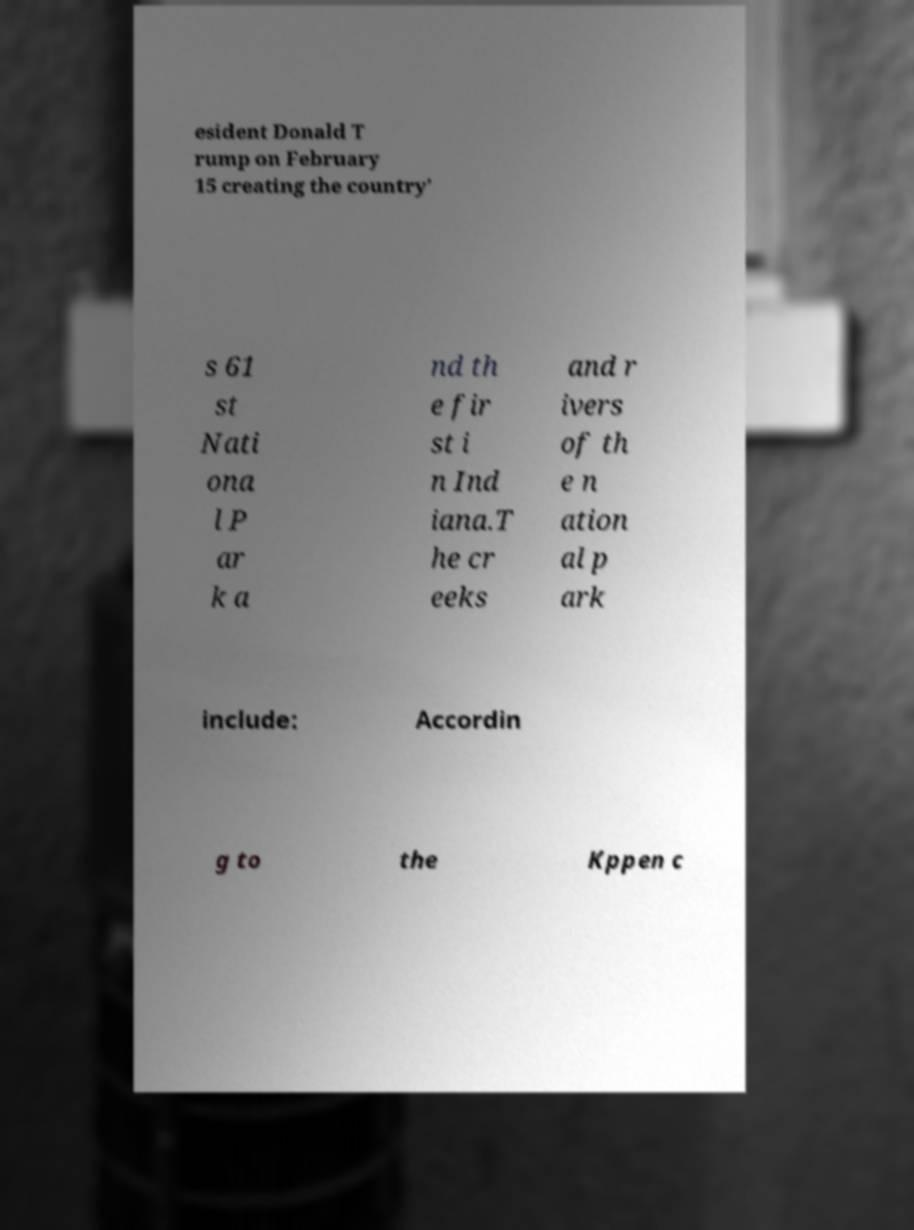Can you read and provide the text displayed in the image?This photo seems to have some interesting text. Can you extract and type it out for me? esident Donald T rump on February 15 creating the country' s 61 st Nati ona l P ar k a nd th e fir st i n Ind iana.T he cr eeks and r ivers of th e n ation al p ark include: Accordin g to the Kppen c 